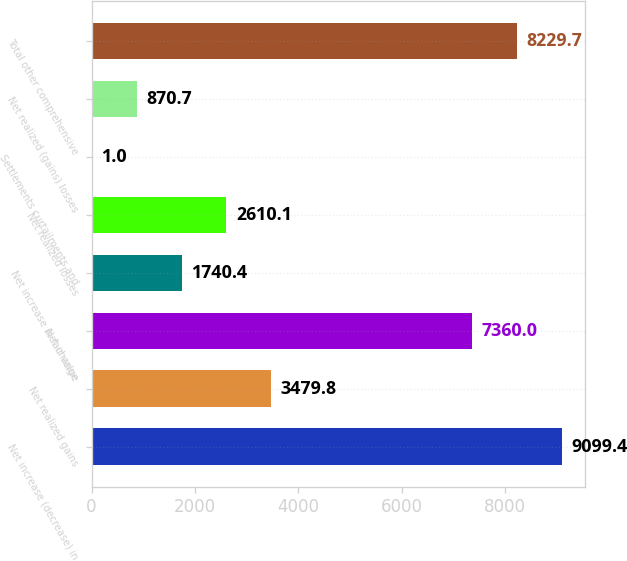Convert chart. <chart><loc_0><loc_0><loc_500><loc_500><bar_chart><fcel>Net increase (decrease) in<fcel>Net realized gains<fcel>Net change<fcel>Net increase in fair value<fcel>Net realized losses<fcel>Settlements curtailments and<fcel>Net realized (gains) losses<fcel>Total other comprehensive<nl><fcel>9099.4<fcel>3479.8<fcel>7360<fcel>1740.4<fcel>2610.1<fcel>1<fcel>870.7<fcel>8229.7<nl></chart> 